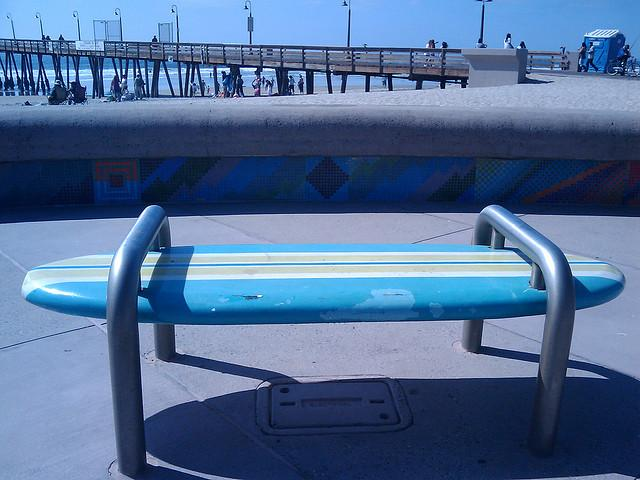What are the bars touching in the foreground? surfboard 